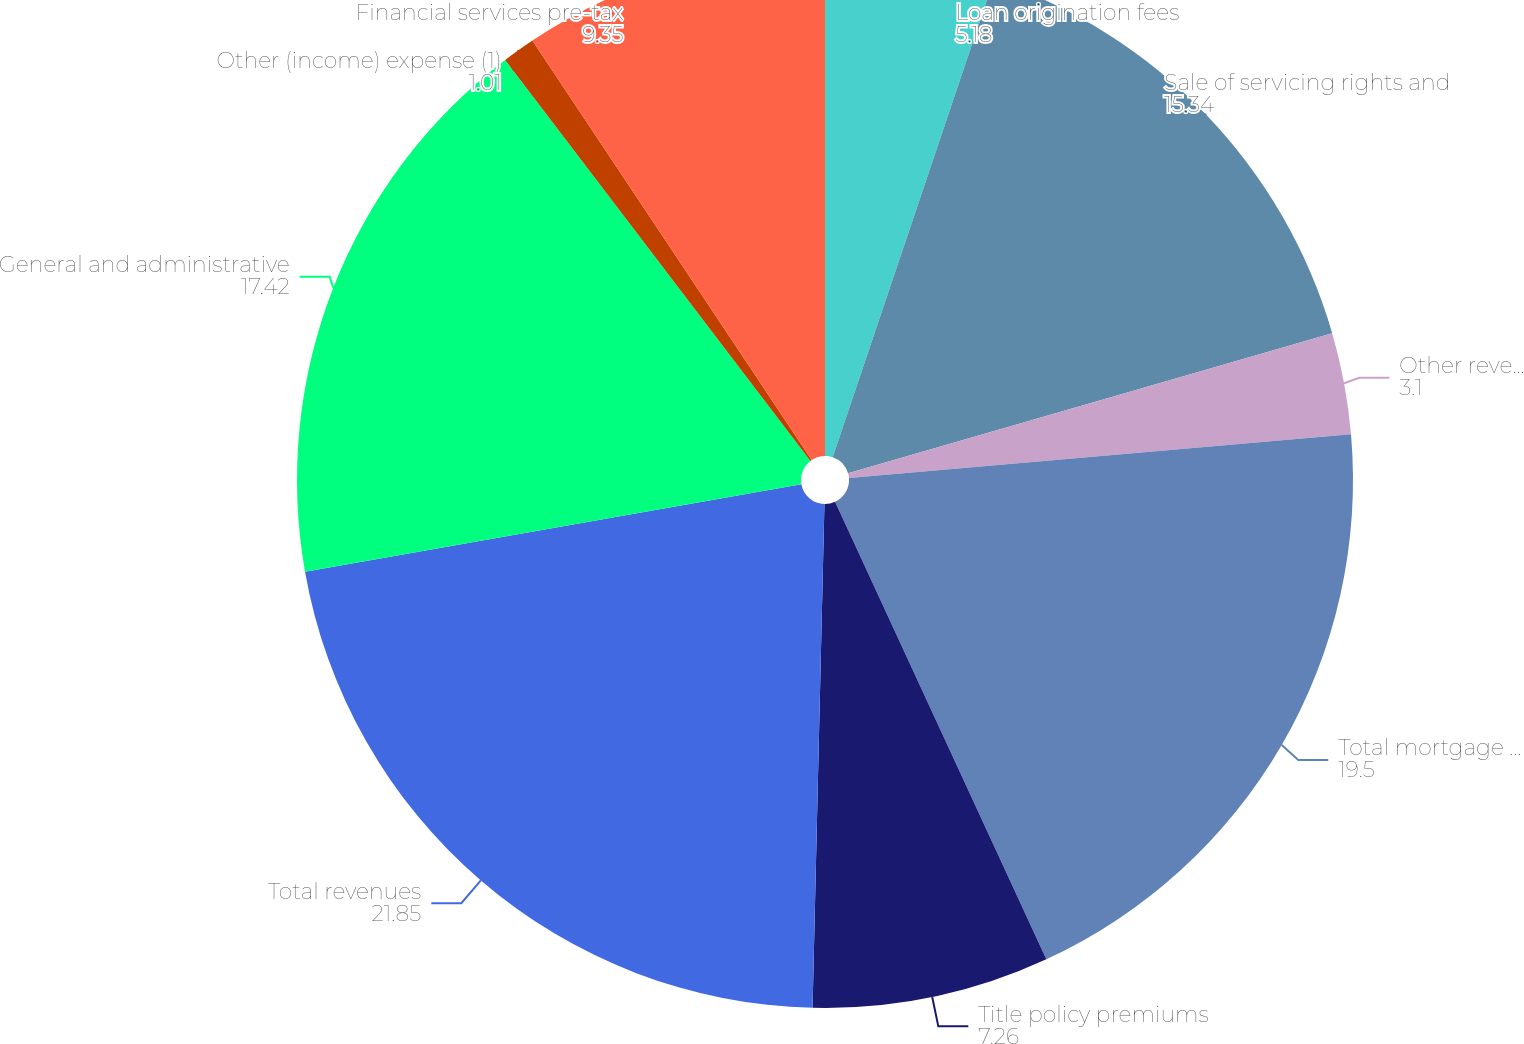<chart> <loc_0><loc_0><loc_500><loc_500><pie_chart><fcel>Loan origination fees<fcel>Sale of servicing rights and<fcel>Other revenues<fcel>Total mortgage operations<fcel>Title policy premiums<fcel>Total revenues<fcel>General and administrative<fcel>Other (income) expense (1)<fcel>Financial services pre-tax<nl><fcel>5.18%<fcel>15.34%<fcel>3.1%<fcel>19.5%<fcel>7.26%<fcel>21.85%<fcel>17.42%<fcel>1.01%<fcel>9.35%<nl></chart> 